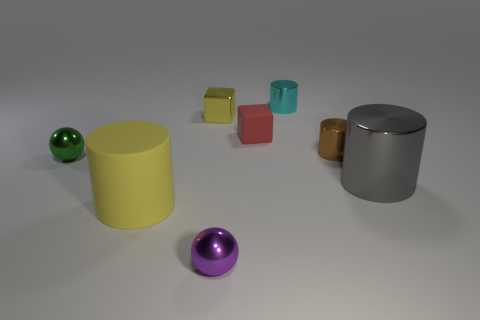Subtract all purple cylinders. Subtract all red blocks. How many cylinders are left? 4 Add 1 small rubber objects. How many objects exist? 9 Subtract all spheres. How many objects are left? 6 Add 4 red rubber objects. How many red rubber objects exist? 5 Subtract 0 green blocks. How many objects are left? 8 Subtract all cyan cylinders. Subtract all tiny brown metallic cylinders. How many objects are left? 6 Add 2 small green metal spheres. How many small green metal spheres are left? 3 